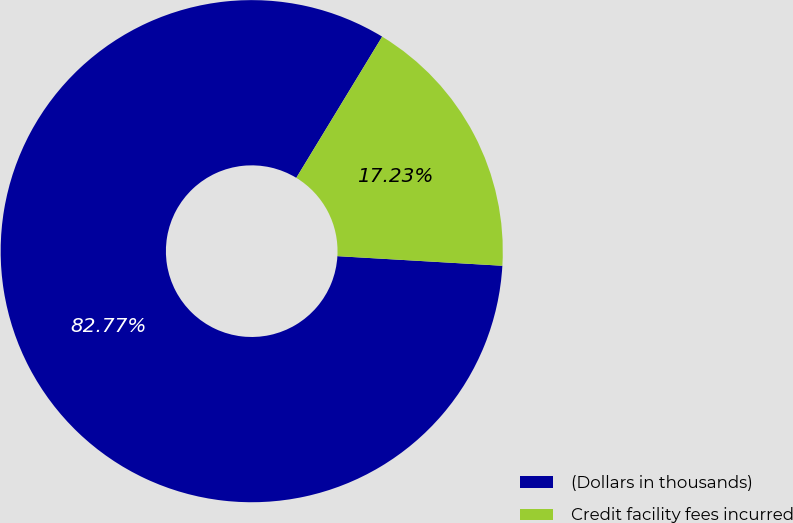Convert chart. <chart><loc_0><loc_0><loc_500><loc_500><pie_chart><fcel>(Dollars in thousands)<fcel>Credit facility fees incurred<nl><fcel>82.77%<fcel>17.23%<nl></chart> 